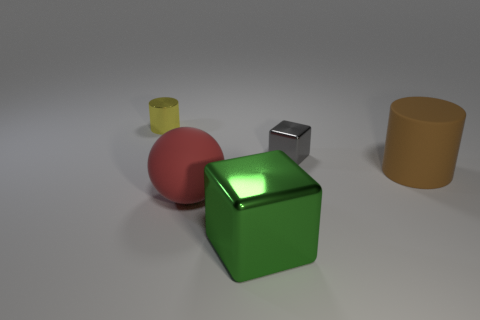Add 5 big brown metallic cylinders. How many objects exist? 10 Subtract all balls. How many objects are left? 4 Add 4 gray metallic blocks. How many gray metallic blocks are left? 5 Add 4 gray metallic objects. How many gray metallic objects exist? 5 Subtract 0 green cylinders. How many objects are left? 5 Subtract all big purple blocks. Subtract all rubber spheres. How many objects are left? 4 